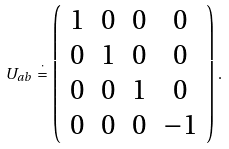Convert formula to latex. <formula><loc_0><loc_0><loc_500><loc_500>U _ { a b } \, \stackrel { \cdot } { = } \, \left ( \begin{array} { c c c c } 1 & 0 & 0 & 0 \\ 0 & 1 & 0 & 0 \\ 0 & 0 & 1 & 0 \\ 0 & 0 & 0 & - 1 \end{array} \right ) \, .</formula> 